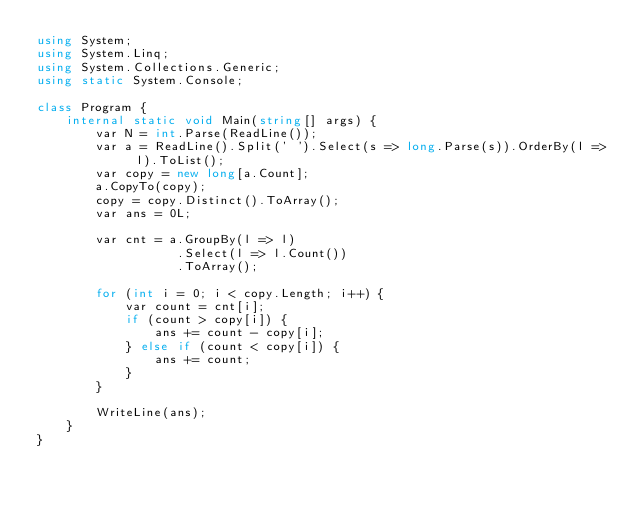Convert code to text. <code><loc_0><loc_0><loc_500><loc_500><_C#_>using System;
using System.Linq;
using System.Collections.Generic;
using static System.Console;

class Program {
    internal static void Main(string[] args) {
        var N = int.Parse(ReadLine());
        var a = ReadLine().Split(' ').Select(s => long.Parse(s)).OrderBy(l => l).ToList();
        var copy = new long[a.Count];
        a.CopyTo(copy);
        copy = copy.Distinct().ToArray();
        var ans = 0L;

        var cnt = a.GroupBy(l => l)
                   .Select(l => l.Count())
                   .ToArray();

        for (int i = 0; i < copy.Length; i++) {
            var count = cnt[i];
            if (count > copy[i]) {
                ans += count - copy[i];
            } else if (count < copy[i]) {
                ans += count;
            }
        }

        WriteLine(ans);
    }
}</code> 